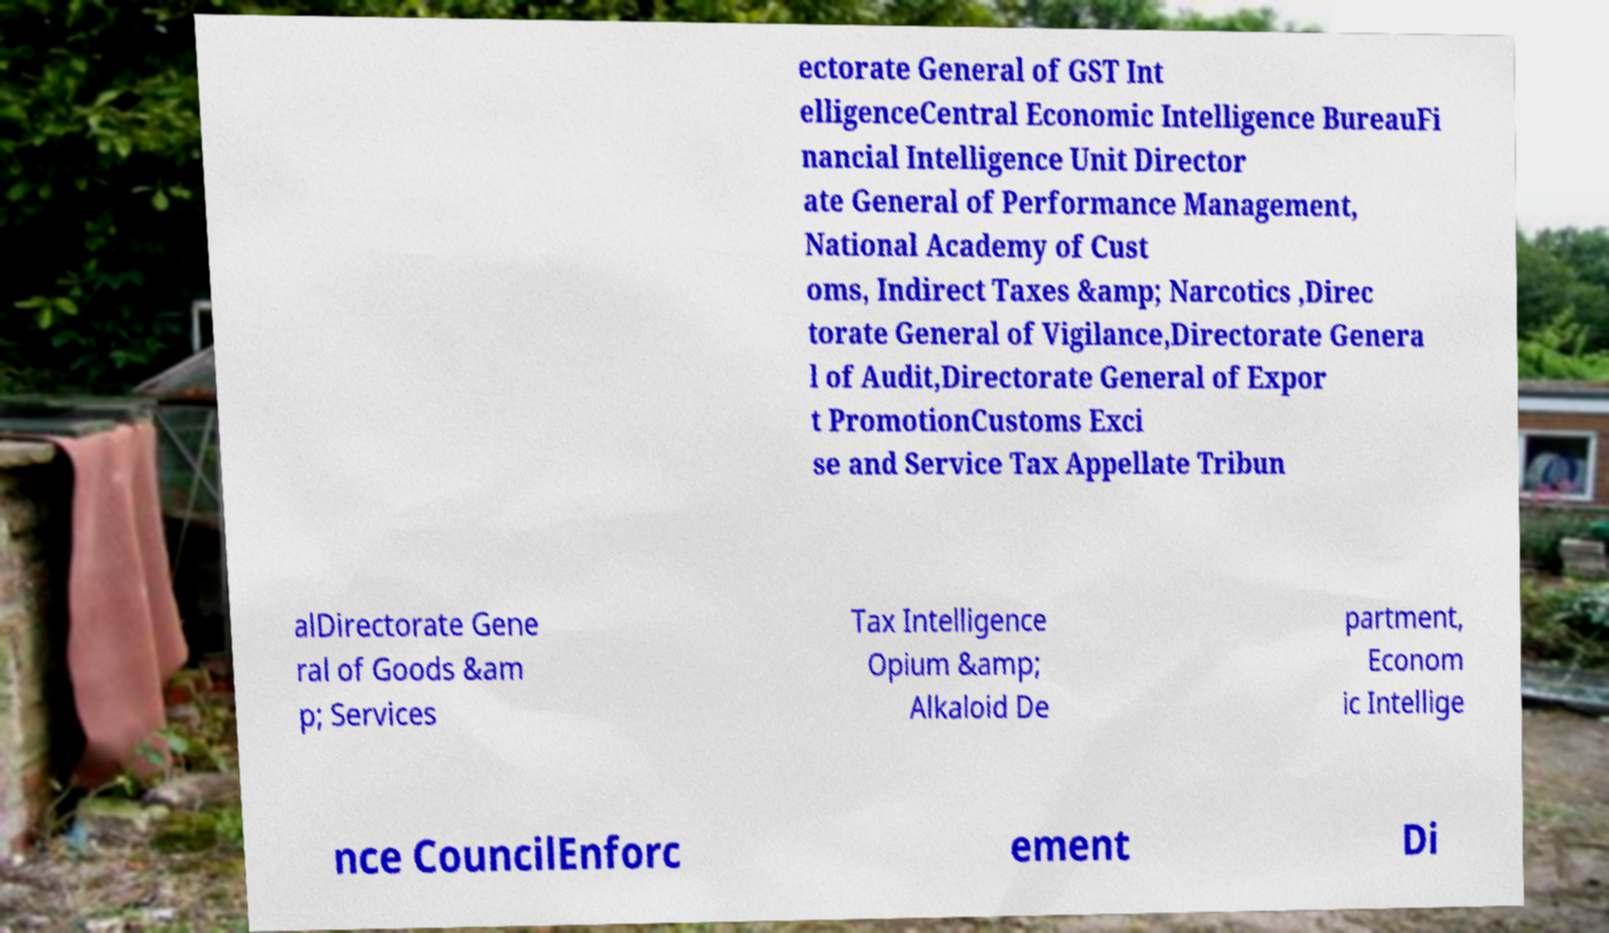Could you assist in decoding the text presented in this image and type it out clearly? ectorate General of GST Int elligenceCentral Economic Intelligence BureauFi nancial Intelligence Unit Director ate General of Performance Management, National Academy of Cust oms, Indirect Taxes &amp; Narcotics ,Direc torate General of Vigilance,Directorate Genera l of Audit,Directorate General of Expor t PromotionCustoms Exci se and Service Tax Appellate Tribun alDirectorate Gene ral of Goods &am p; Services Tax Intelligence Opium &amp; Alkaloid De partment, Econom ic Intellige nce CouncilEnforc ement Di 